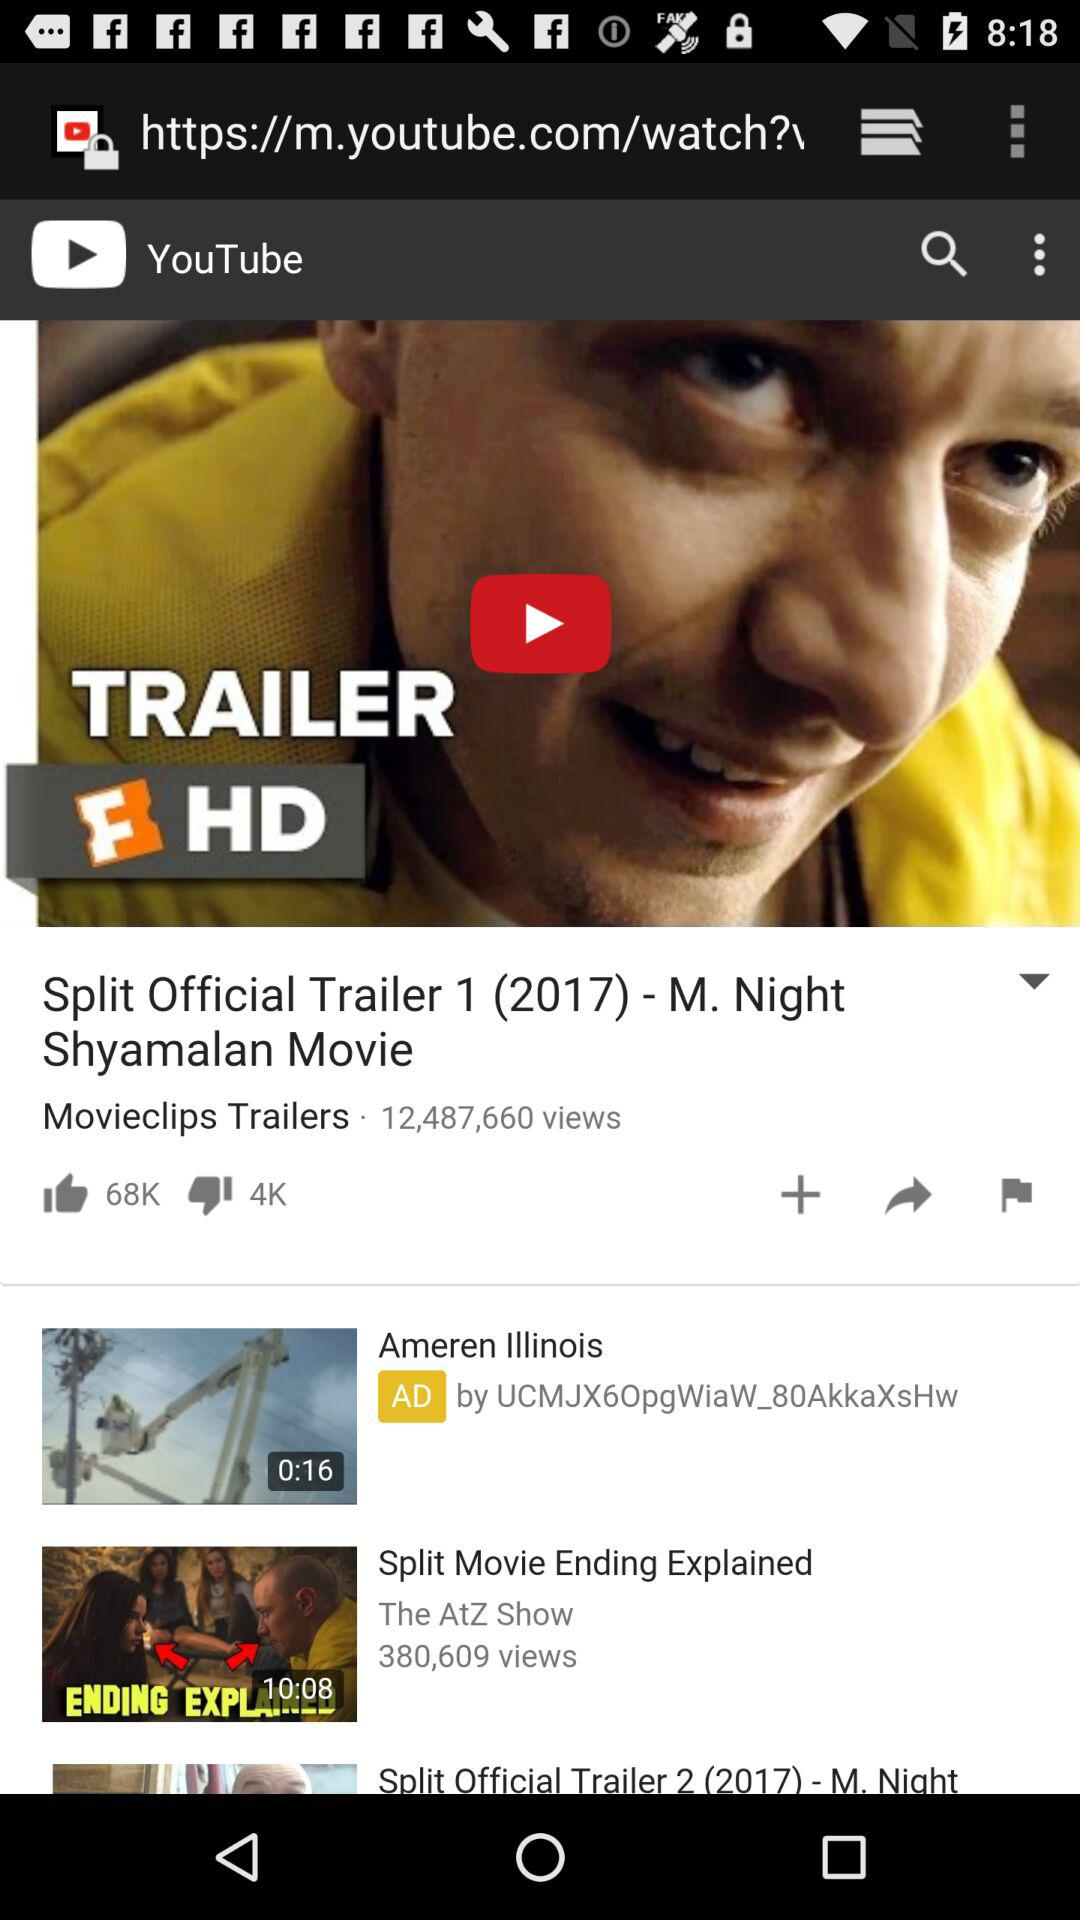How many views does the trailer have?
Answer the question using a single word or phrase. 12,487,660 views 